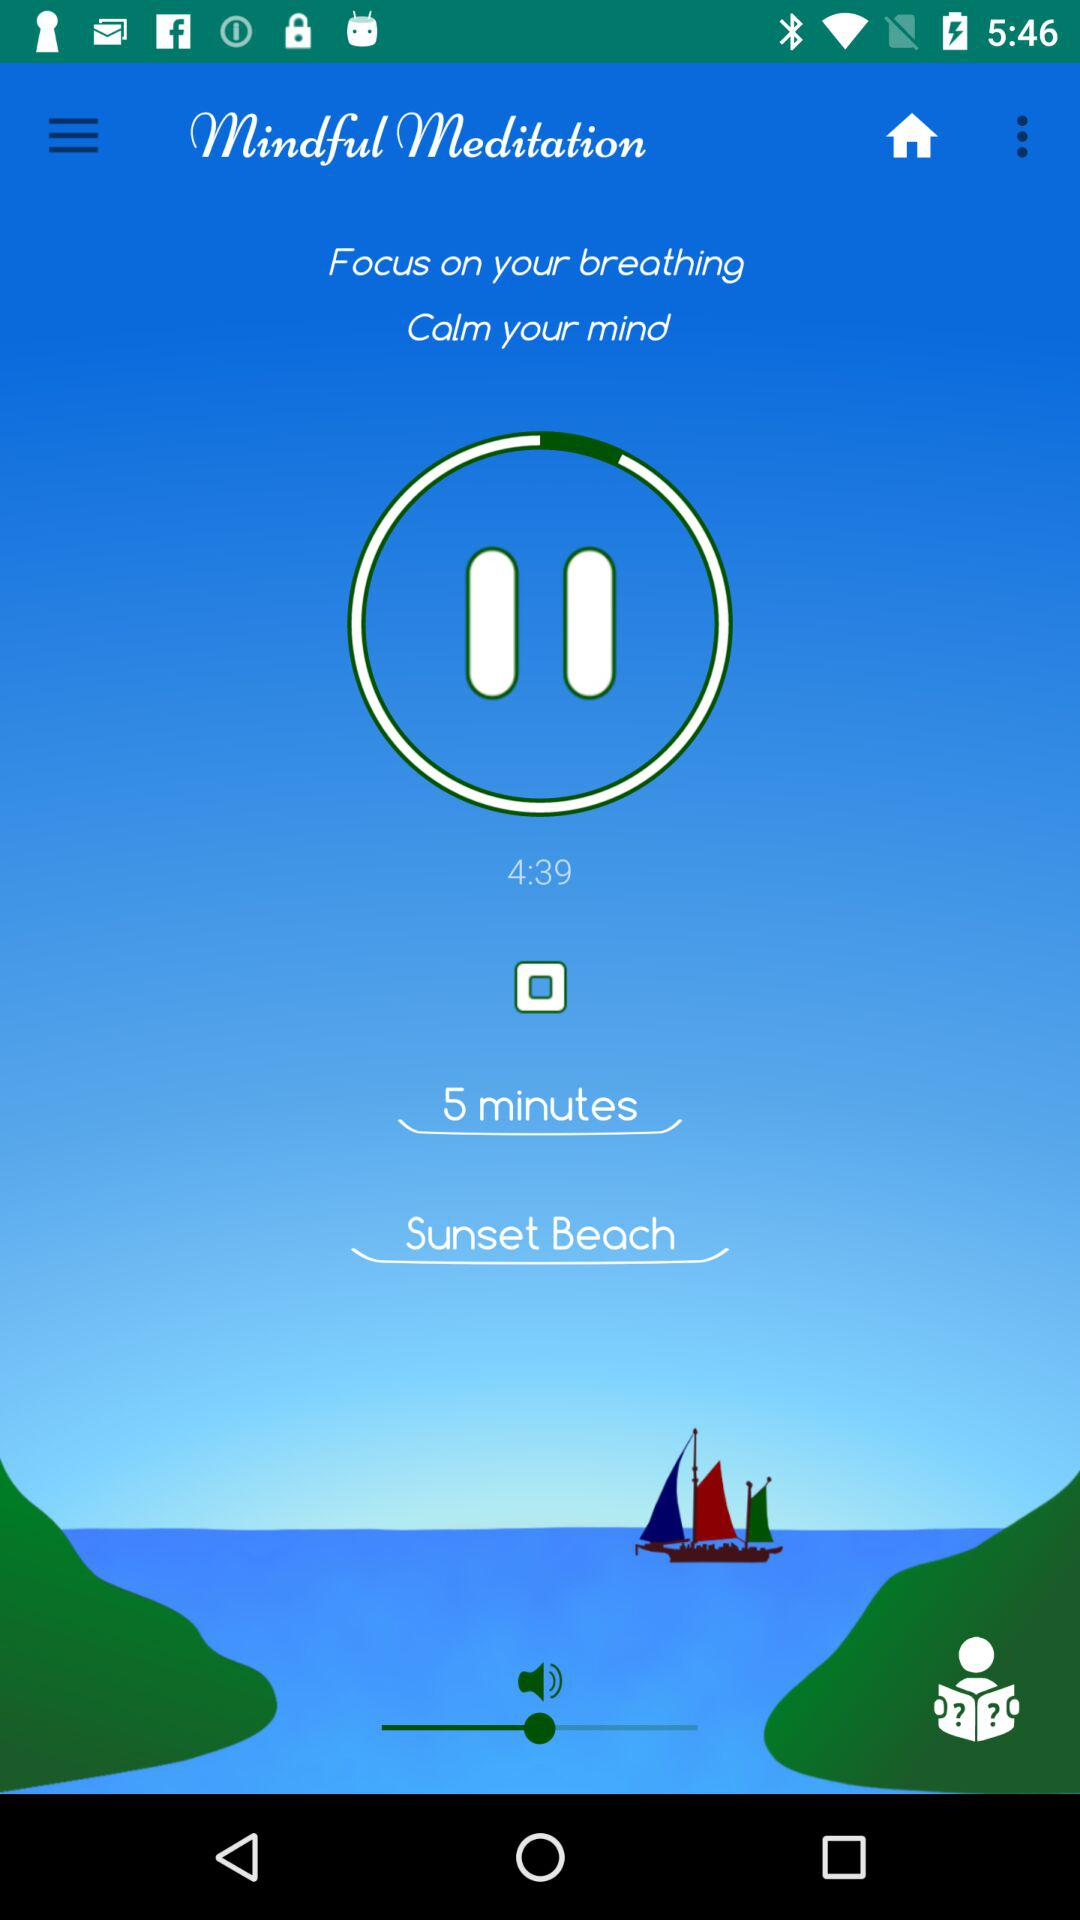What is the set time on the timer? The time set on the timer is 5 minutes. 